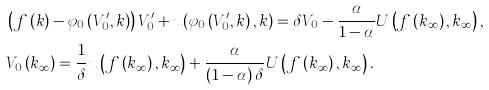<formula> <loc_0><loc_0><loc_500><loc_500>& \left ( f \left ( k \right ) - \varphi _ { 0 } \left ( V _ { 0 } ^ { \prime } , k \right ) \right ) V _ { 0 } ^ { \prime } + u ( \varphi _ { 0 } \left ( V _ { 0 } ^ { \prime } , k \right ) , k ) = \delta V _ { 0 } - \frac { \alpha } { 1 - \alpha } U \left ( f \left ( k _ { \infty } \right ) , k _ { \infty } \right ) , \\ & V _ { 0 } \left ( k _ { \infty } \right ) = \frac { 1 } { \delta } u \left ( f \left ( k _ { \infty } \right ) , k _ { \infty } \right ) + \frac { \alpha } { \left ( 1 - \alpha \right ) \delta } U \left ( f \left ( k _ { \infty } \right ) , k _ { \infty } \right ) .</formula> 